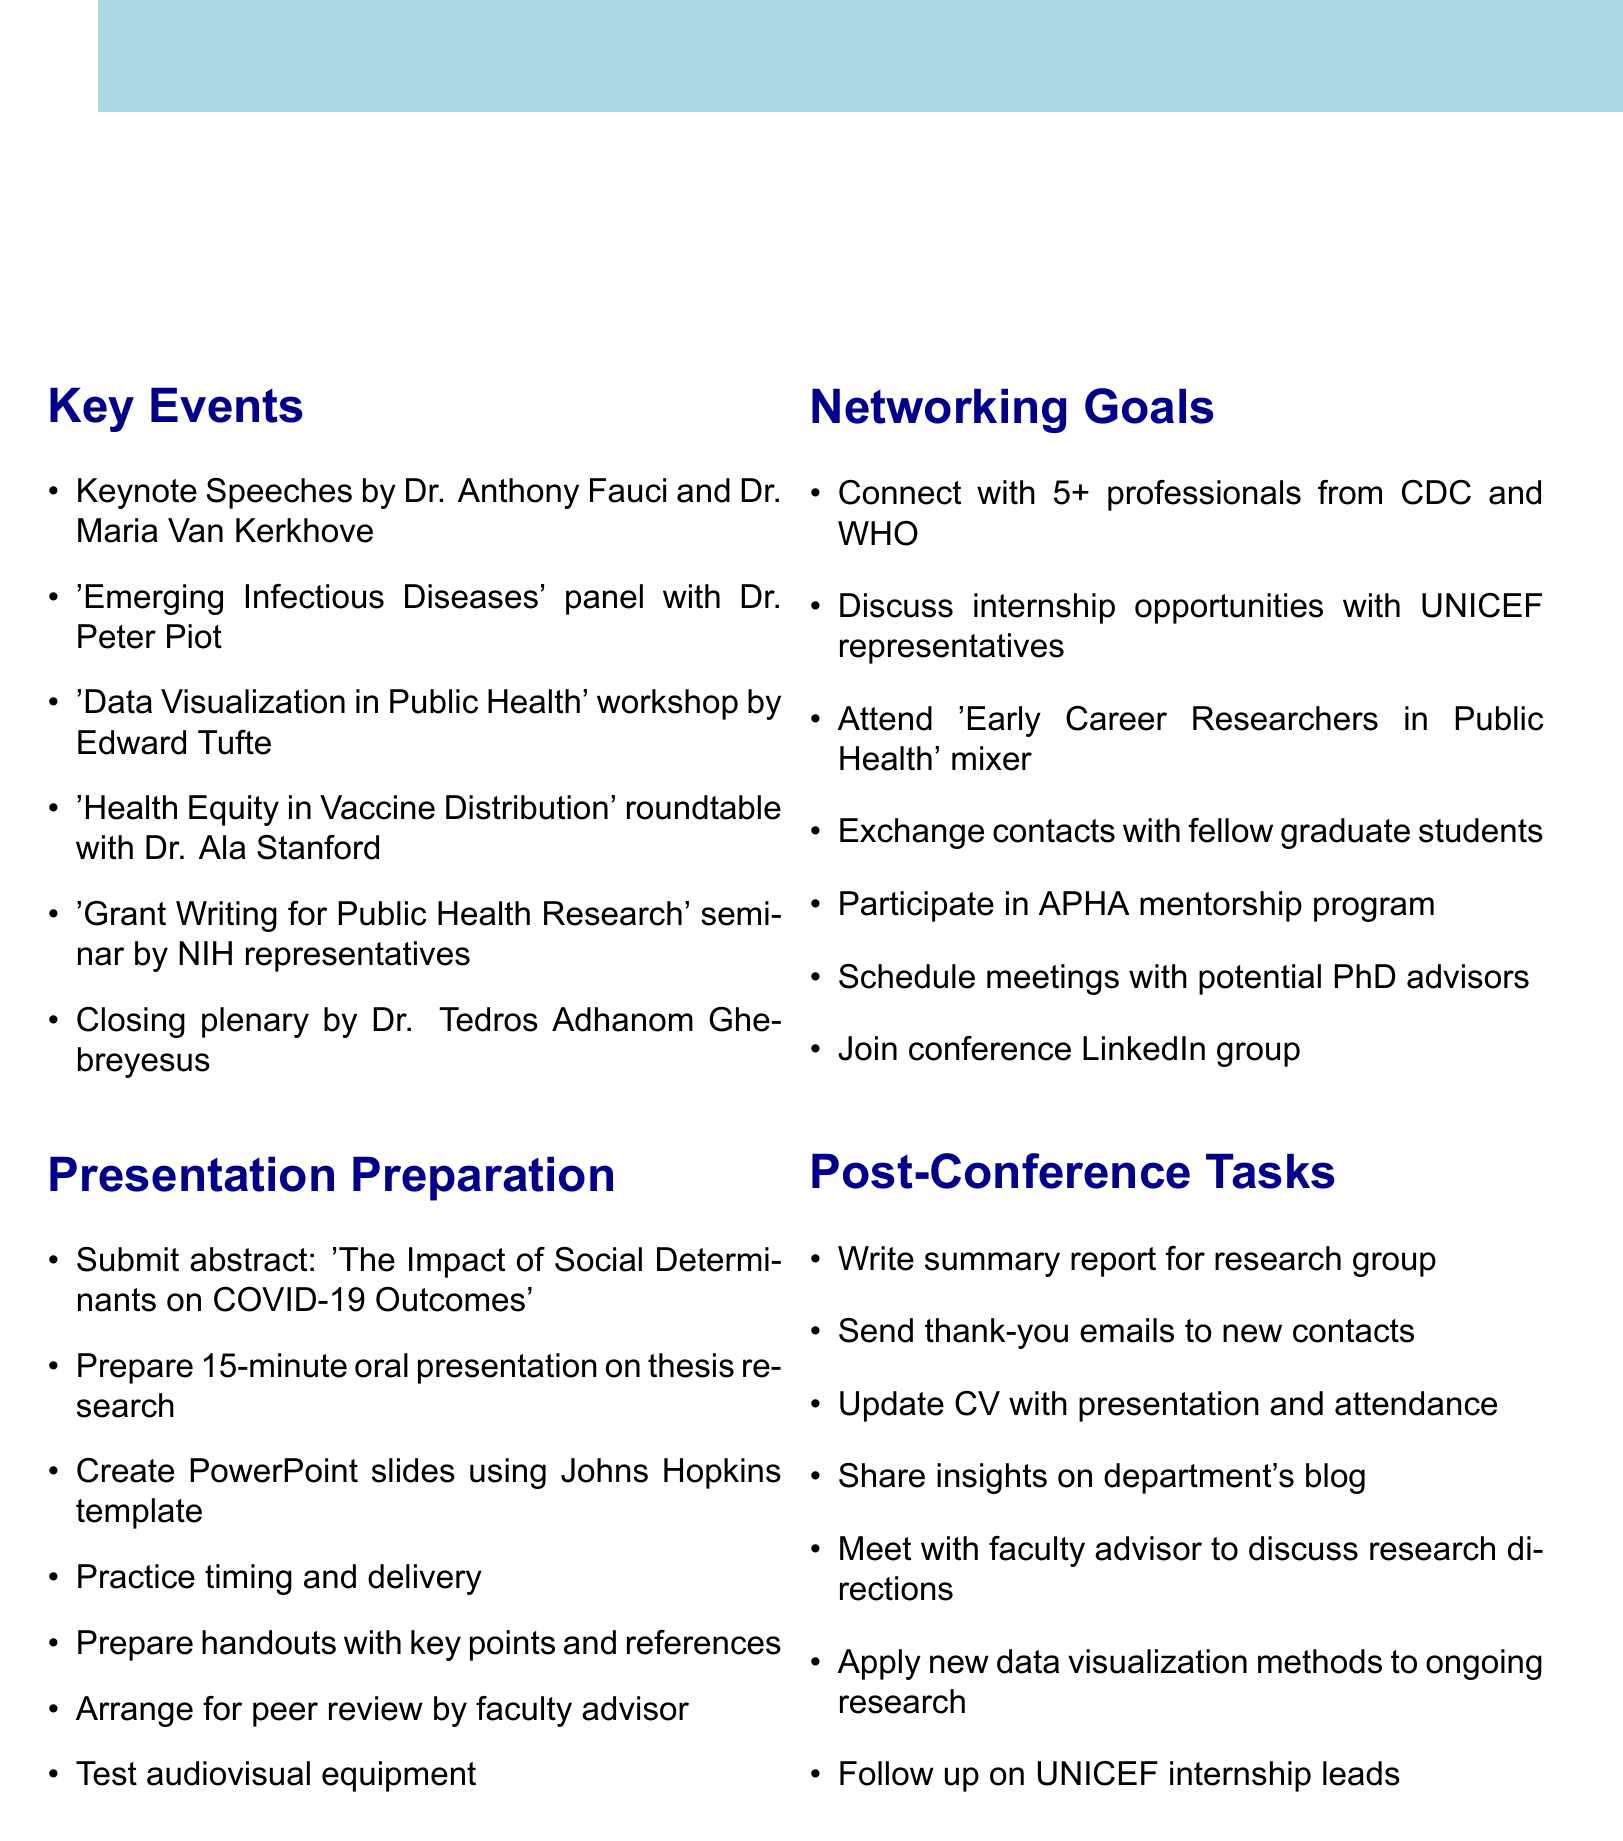What are the dates of the symposium? The dates of the symposium are mentioned in the document as October 15-17, 2023.
Answer: October 15-17, 2023 Who are the keynote speakers? The document lists Dr. Anthony Fauci and Dr. Maria Van Kerkhove as the keynote speakers.
Answer: Dr. Anthony Fauci and Dr. Maria Van Kerkhove What is the allocated budget for the conference? The budget is stated as $50,000 for venue, catering, and materials.
Answer: $50,000 How many professionals does the networking goal aim to connect with from CDC and WHO? The goal specifies connecting with at least 5 professionals from the CDC and WHO.
Answer: 5 What is the title of the oral presentation to be prepared? The title of the oral presentation is not explicitly stated, but it's focused on thesis research.
Answer: Thesis research Which workshop is led by Edward Tufte? The document identifies 'Data Visualization in Public Health' as the workshop led by Edward Tufte.
Answer: Data Visualization in Public Health What should be included in the thank-you emails after the conference? The document states that thank-you emails should be sent to new contacts and potential mentors.
Answer: New contacts and potential mentors What is one task mentioned for post-conference follow-up? Writing a summary report of key learnings for the research group is mentioned as a task.
Answer: Summary report of key learnings 